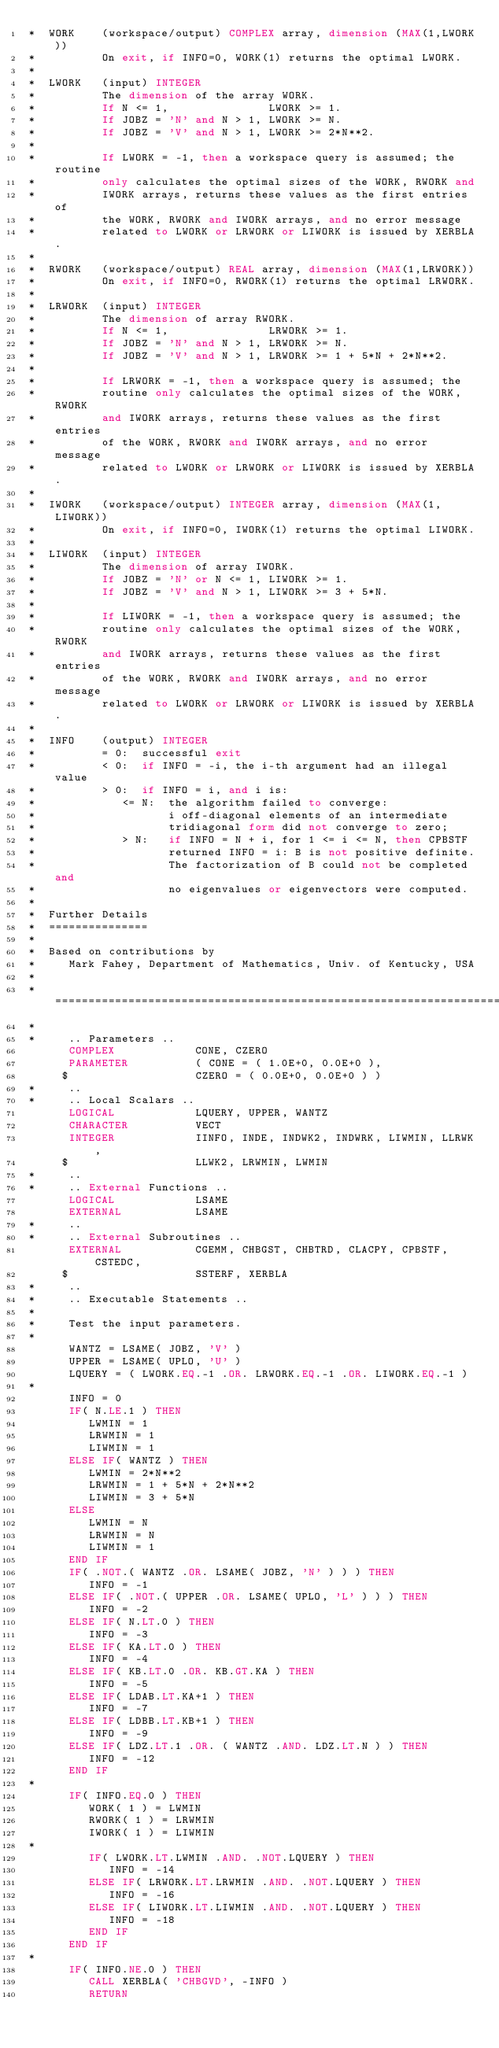Convert code to text. <code><loc_0><loc_0><loc_500><loc_500><_FORTRAN_>*  WORK    (workspace/output) COMPLEX array, dimension (MAX(1,LWORK))
*          On exit, if INFO=0, WORK(1) returns the optimal LWORK.
*
*  LWORK   (input) INTEGER
*          The dimension of the array WORK.
*          If N <= 1,               LWORK >= 1.
*          If JOBZ = 'N' and N > 1, LWORK >= N.
*          If JOBZ = 'V' and N > 1, LWORK >= 2*N**2.
*
*          If LWORK = -1, then a workspace query is assumed; the routine
*          only calculates the optimal sizes of the WORK, RWORK and
*          IWORK arrays, returns these values as the first entries of
*          the WORK, RWORK and IWORK arrays, and no error message
*          related to LWORK or LRWORK or LIWORK is issued by XERBLA.
*
*  RWORK   (workspace/output) REAL array, dimension (MAX(1,LRWORK))
*          On exit, if INFO=0, RWORK(1) returns the optimal LRWORK.
*
*  LRWORK  (input) INTEGER
*          The dimension of array RWORK.
*          If N <= 1,               LRWORK >= 1.
*          If JOBZ = 'N' and N > 1, LRWORK >= N.
*          If JOBZ = 'V' and N > 1, LRWORK >= 1 + 5*N + 2*N**2.
*
*          If LRWORK = -1, then a workspace query is assumed; the
*          routine only calculates the optimal sizes of the WORK, RWORK
*          and IWORK arrays, returns these values as the first entries
*          of the WORK, RWORK and IWORK arrays, and no error message
*          related to LWORK or LRWORK or LIWORK is issued by XERBLA.
*
*  IWORK   (workspace/output) INTEGER array, dimension (MAX(1,LIWORK))
*          On exit, if INFO=0, IWORK(1) returns the optimal LIWORK.
*
*  LIWORK  (input) INTEGER
*          The dimension of array IWORK.
*          If JOBZ = 'N' or N <= 1, LIWORK >= 1.
*          If JOBZ = 'V' and N > 1, LIWORK >= 3 + 5*N.
*
*          If LIWORK = -1, then a workspace query is assumed; the
*          routine only calculates the optimal sizes of the WORK, RWORK
*          and IWORK arrays, returns these values as the first entries
*          of the WORK, RWORK and IWORK arrays, and no error message
*          related to LWORK or LRWORK or LIWORK is issued by XERBLA.
*
*  INFO    (output) INTEGER
*          = 0:  successful exit
*          < 0:  if INFO = -i, the i-th argument had an illegal value
*          > 0:  if INFO = i, and i is:
*             <= N:  the algorithm failed to converge:
*                    i off-diagonal elements of an intermediate
*                    tridiagonal form did not converge to zero;
*             > N:   if INFO = N + i, for 1 <= i <= N, then CPBSTF
*                    returned INFO = i: B is not positive definite.
*                    The factorization of B could not be completed and
*                    no eigenvalues or eigenvectors were computed.
*
*  Further Details
*  ===============
*
*  Based on contributions by
*     Mark Fahey, Department of Mathematics, Univ. of Kentucky, USA
*
*  =====================================================================
*
*     .. Parameters ..
      COMPLEX            CONE, CZERO
      PARAMETER          ( CONE = ( 1.0E+0, 0.0E+0 ),
     $                   CZERO = ( 0.0E+0, 0.0E+0 ) )
*     ..
*     .. Local Scalars ..
      LOGICAL            LQUERY, UPPER, WANTZ
      CHARACTER          VECT
      INTEGER            IINFO, INDE, INDWK2, INDWRK, LIWMIN, LLRWK,
     $                   LLWK2, LRWMIN, LWMIN
*     ..
*     .. External Functions ..
      LOGICAL            LSAME
      EXTERNAL           LSAME
*     ..
*     .. External Subroutines ..
      EXTERNAL           CGEMM, CHBGST, CHBTRD, CLACPY, CPBSTF, CSTEDC,
     $                   SSTERF, XERBLA
*     ..
*     .. Executable Statements ..
*
*     Test the input parameters.
*
      WANTZ = LSAME( JOBZ, 'V' )
      UPPER = LSAME( UPLO, 'U' )
      LQUERY = ( LWORK.EQ.-1 .OR. LRWORK.EQ.-1 .OR. LIWORK.EQ.-1 )
*
      INFO = 0
      IF( N.LE.1 ) THEN
         LWMIN = 1
         LRWMIN = 1
         LIWMIN = 1
      ELSE IF( WANTZ ) THEN
         LWMIN = 2*N**2
         LRWMIN = 1 + 5*N + 2*N**2
         LIWMIN = 3 + 5*N
      ELSE
         LWMIN = N
         LRWMIN = N
         LIWMIN = 1
      END IF
      IF( .NOT.( WANTZ .OR. LSAME( JOBZ, 'N' ) ) ) THEN
         INFO = -1
      ELSE IF( .NOT.( UPPER .OR. LSAME( UPLO, 'L' ) ) ) THEN
         INFO = -2
      ELSE IF( N.LT.0 ) THEN
         INFO = -3
      ELSE IF( KA.LT.0 ) THEN
         INFO = -4
      ELSE IF( KB.LT.0 .OR. KB.GT.KA ) THEN
         INFO = -5
      ELSE IF( LDAB.LT.KA+1 ) THEN
         INFO = -7
      ELSE IF( LDBB.LT.KB+1 ) THEN
         INFO = -9
      ELSE IF( LDZ.LT.1 .OR. ( WANTZ .AND. LDZ.LT.N ) ) THEN
         INFO = -12
      END IF
*
      IF( INFO.EQ.0 ) THEN
         WORK( 1 ) = LWMIN
         RWORK( 1 ) = LRWMIN
         IWORK( 1 ) = LIWMIN
*
         IF( LWORK.LT.LWMIN .AND. .NOT.LQUERY ) THEN
            INFO = -14
         ELSE IF( LRWORK.LT.LRWMIN .AND. .NOT.LQUERY ) THEN
            INFO = -16
         ELSE IF( LIWORK.LT.LIWMIN .AND. .NOT.LQUERY ) THEN
            INFO = -18
         END IF
      END IF
*
      IF( INFO.NE.0 ) THEN
         CALL XERBLA( 'CHBGVD', -INFO )
         RETURN</code> 